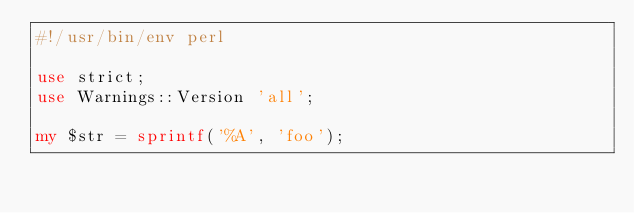<code> <loc_0><loc_0><loc_500><loc_500><_Perl_>#!/usr/bin/env perl

use strict;
use Warnings::Version 'all';

my $str = sprintf('%A', 'foo');
</code> 